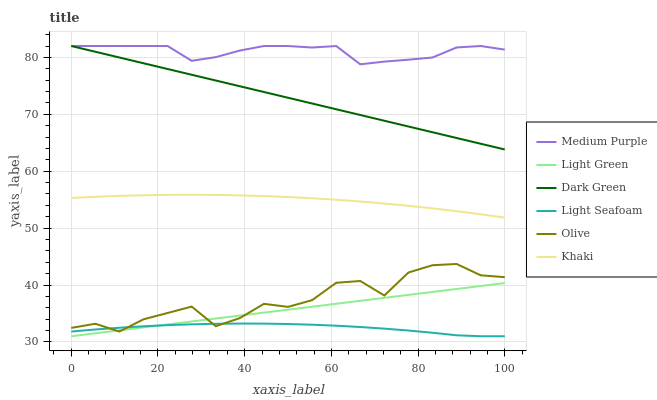Does Light Seafoam have the minimum area under the curve?
Answer yes or no. Yes. Does Medium Purple have the maximum area under the curve?
Answer yes or no. Yes. Does Light Green have the minimum area under the curve?
Answer yes or no. No. Does Light Green have the maximum area under the curve?
Answer yes or no. No. Is Light Green the smoothest?
Answer yes or no. Yes. Is Olive the roughest?
Answer yes or no. Yes. Is Medium Purple the smoothest?
Answer yes or no. No. Is Medium Purple the roughest?
Answer yes or no. No. Does Medium Purple have the lowest value?
Answer yes or no. No. Does Light Green have the highest value?
Answer yes or no. No. Is Light Seafoam less than Medium Purple?
Answer yes or no. Yes. Is Medium Purple greater than Khaki?
Answer yes or no. Yes. Does Light Seafoam intersect Medium Purple?
Answer yes or no. No. 